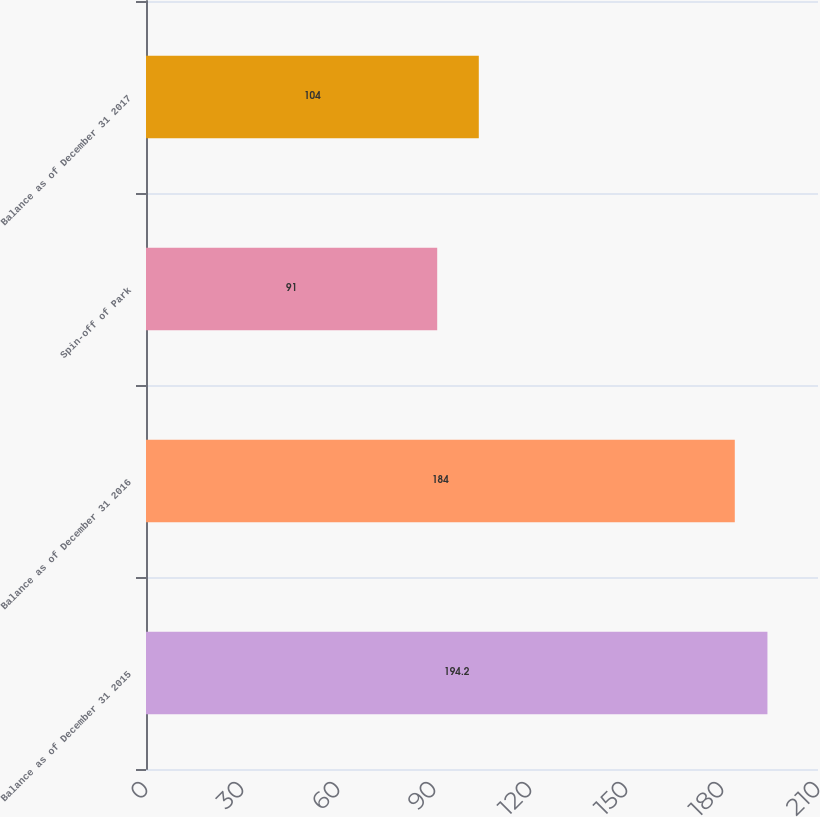Convert chart to OTSL. <chart><loc_0><loc_0><loc_500><loc_500><bar_chart><fcel>Balance as of December 31 2015<fcel>Balance as of December 31 2016<fcel>Spin-off of Park<fcel>Balance as of December 31 2017<nl><fcel>194.2<fcel>184<fcel>91<fcel>104<nl></chart> 